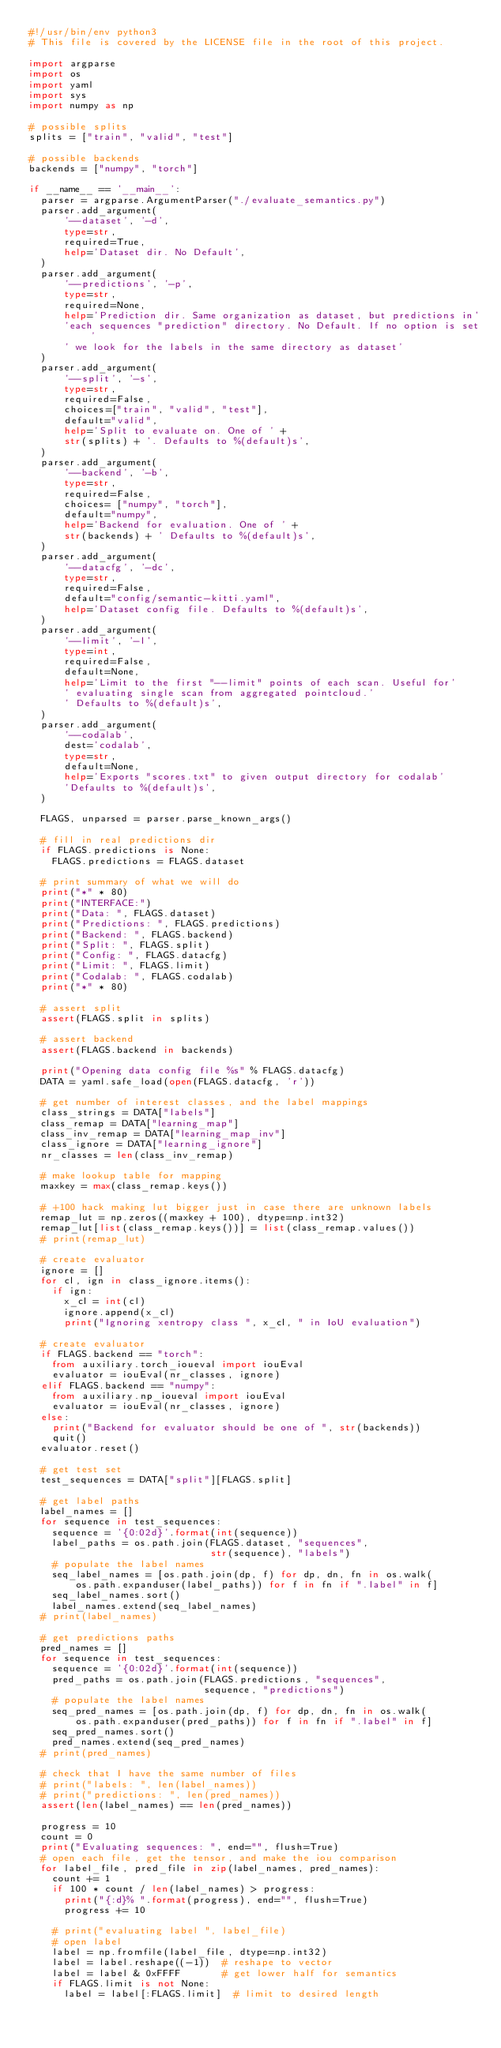<code> <loc_0><loc_0><loc_500><loc_500><_Python_>#!/usr/bin/env python3
# This file is covered by the LICENSE file in the root of this project.

import argparse
import os
import yaml
import sys
import numpy as np

# possible splits
splits = ["train", "valid", "test"]

# possible backends
backends = ["numpy", "torch"]

if __name__ == '__main__':
  parser = argparse.ArgumentParser("./evaluate_semantics.py")
  parser.add_argument(
      '--dataset', '-d',
      type=str,
      required=True,
      help='Dataset dir. No Default',
  )
  parser.add_argument(
      '--predictions', '-p',
      type=str,
      required=None,
      help='Prediction dir. Same organization as dataset, but predictions in'
      'each sequences "prediction" directory. No Default. If no option is set'
      ' we look for the labels in the same directory as dataset'
  )
  parser.add_argument(
      '--split', '-s',
      type=str,
      required=False,
      choices=["train", "valid", "test"],
      default="valid",
      help='Split to evaluate on. One of ' +
      str(splits) + '. Defaults to %(default)s',
  )
  parser.add_argument(
      '--backend', '-b',
      type=str,
      required=False,
      choices= ["numpy", "torch"],
      default="numpy",
      help='Backend for evaluation. One of ' +
      str(backends) + ' Defaults to %(default)s',
  )
  parser.add_argument(
      '--datacfg', '-dc',
      type=str,
      required=False,
      default="config/semantic-kitti.yaml",
      help='Dataset config file. Defaults to %(default)s',
  )
  parser.add_argument(
      '--limit', '-l',
      type=int,
      required=False,
      default=None,
      help='Limit to the first "--limit" points of each scan. Useful for'
      ' evaluating single scan from aggregated pointcloud.'
      ' Defaults to %(default)s',
  )
  parser.add_argument(
      '--codalab',
      dest='codalab',
      type=str,
      default=None,
      help='Exports "scores.txt" to given output directory for codalab'
      'Defaults to %(default)s',
  )

  FLAGS, unparsed = parser.parse_known_args()

  # fill in real predictions dir
  if FLAGS.predictions is None:
    FLAGS.predictions = FLAGS.dataset

  # print summary of what we will do
  print("*" * 80)
  print("INTERFACE:")
  print("Data: ", FLAGS.dataset)
  print("Predictions: ", FLAGS.predictions)
  print("Backend: ", FLAGS.backend)
  print("Split: ", FLAGS.split)
  print("Config: ", FLAGS.datacfg)
  print("Limit: ", FLAGS.limit)
  print("Codalab: ", FLAGS.codalab)
  print("*" * 80)

  # assert split
  assert(FLAGS.split in splits)

  # assert backend
  assert(FLAGS.backend in backends)

  print("Opening data config file %s" % FLAGS.datacfg)
  DATA = yaml.safe_load(open(FLAGS.datacfg, 'r'))

  # get number of interest classes, and the label mappings
  class_strings = DATA["labels"]
  class_remap = DATA["learning_map"]
  class_inv_remap = DATA["learning_map_inv"]
  class_ignore = DATA["learning_ignore"]
  nr_classes = len(class_inv_remap)

  # make lookup table for mapping
  maxkey = max(class_remap.keys())
  
  # +100 hack making lut bigger just in case there are unknown labels
  remap_lut = np.zeros((maxkey + 100), dtype=np.int32)
  remap_lut[list(class_remap.keys())] = list(class_remap.values())
  # print(remap_lut)

  # create evaluator
  ignore = []
  for cl, ign in class_ignore.items():
    if ign:
      x_cl = int(cl)
      ignore.append(x_cl)
      print("Ignoring xentropy class ", x_cl, " in IoU evaluation")

  # create evaluator
  if FLAGS.backend == "torch":
    from auxiliary.torch_ioueval import iouEval
    evaluator = iouEval(nr_classes, ignore)
  elif FLAGS.backend == "numpy":
    from auxiliary.np_ioueval import iouEval
    evaluator = iouEval(nr_classes, ignore)
  else:
    print("Backend for evaluator should be one of ", str(backends))
    quit()
  evaluator.reset()

  # get test set
  test_sequences = DATA["split"][FLAGS.split]

  # get label paths
  label_names = []
  for sequence in test_sequences:
    sequence = '{0:02d}'.format(int(sequence))
    label_paths = os.path.join(FLAGS.dataset, "sequences",
                               str(sequence), "labels")
    # populate the label names
    seq_label_names = [os.path.join(dp, f) for dp, dn, fn in os.walk(
        os.path.expanduser(label_paths)) for f in fn if ".label" in f]
    seq_label_names.sort()
    label_names.extend(seq_label_names)
  # print(label_names)

  # get predictions paths
  pred_names = []
  for sequence in test_sequences:
    sequence = '{0:02d}'.format(int(sequence))
    pred_paths = os.path.join(FLAGS.predictions, "sequences",
                              sequence, "predictions")
    # populate the label names
    seq_pred_names = [os.path.join(dp, f) for dp, dn, fn in os.walk(
        os.path.expanduser(pred_paths)) for f in fn if ".label" in f]
    seq_pred_names.sort()
    pred_names.extend(seq_pred_names)
  # print(pred_names)

  # check that I have the same number of files
  # print("labels: ", len(label_names))
  # print("predictions: ", len(pred_names))
  assert(len(label_names) == len(pred_names))

  progress = 10
  count = 0
  print("Evaluating sequences: ", end="", flush=True)
  # open each file, get the tensor, and make the iou comparison
  for label_file, pred_file in zip(label_names, pred_names):
    count += 1
    if 100 * count / len(label_names) > progress:
      print("{:d}% ".format(progress), end="", flush=True)
      progress += 10

    # print("evaluating label ", label_file)
    # open label
    label = np.fromfile(label_file, dtype=np.int32)
    label = label.reshape((-1))  # reshape to vector
    label = label & 0xFFFF       # get lower half for semantics
    if FLAGS.limit is not None:
      label = label[:FLAGS.limit]  # limit to desired length</code> 